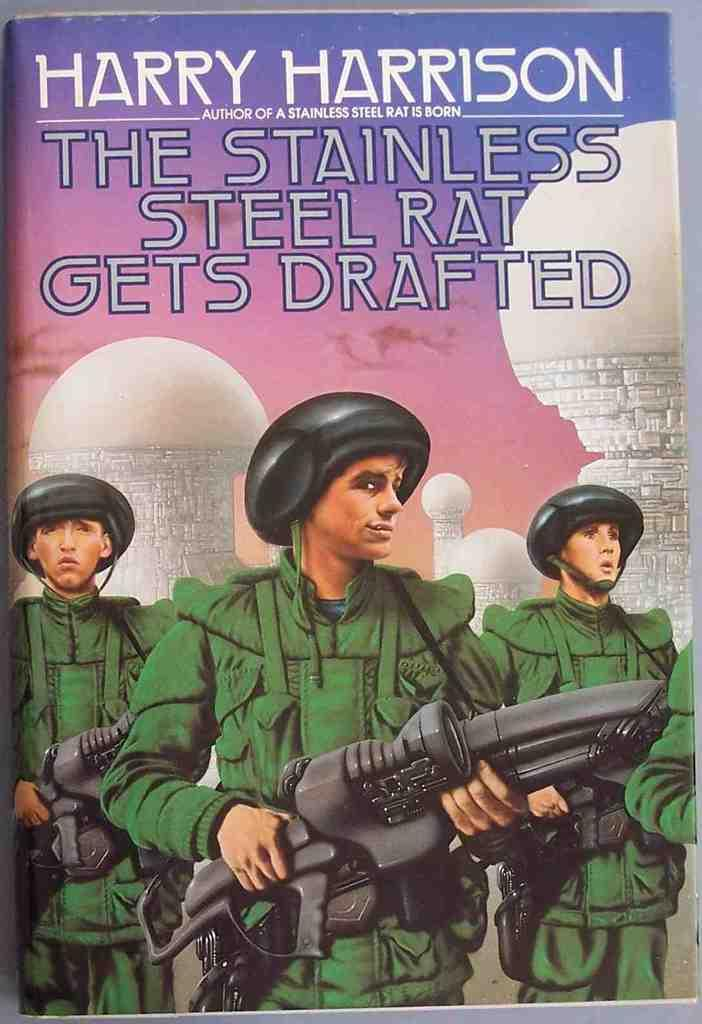<image>
Offer a succinct explanation of the picture presented. A book by Harry Harrison called The Stainless Steel Rat Gets Drafted. 